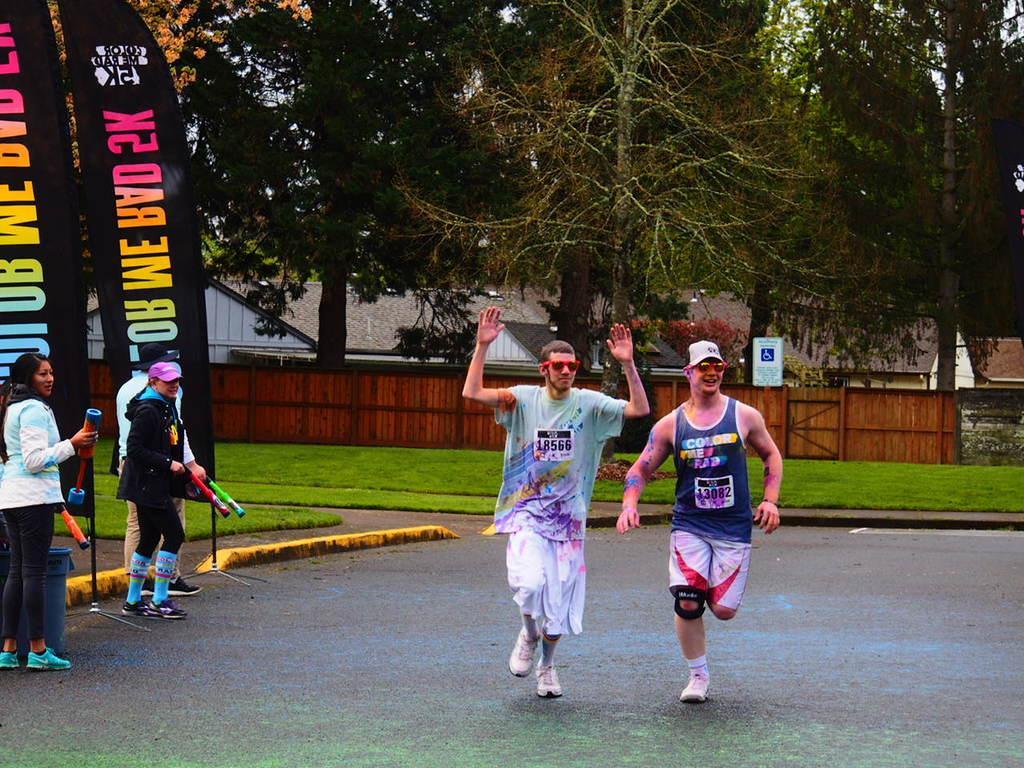How would you summarize this image in a sentence or two? In this image we can see two men are running on the road. Left side of the image persons are standing by holding colors container in their hand. Behind them black color boards are there. Background of the image tree, wooden fencing and houses are there. In front of the fencing grassy land is present. 